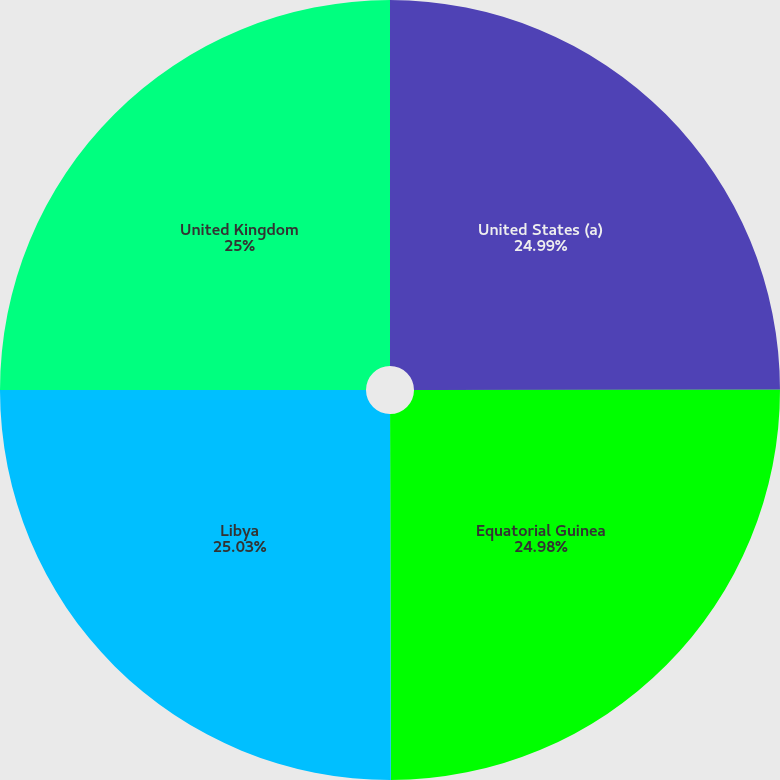<chart> <loc_0><loc_0><loc_500><loc_500><pie_chart><fcel>United States (a)<fcel>Equatorial Guinea<fcel>Libya<fcel>United Kingdom<nl><fcel>24.99%<fcel>24.98%<fcel>25.04%<fcel>25.0%<nl></chart> 